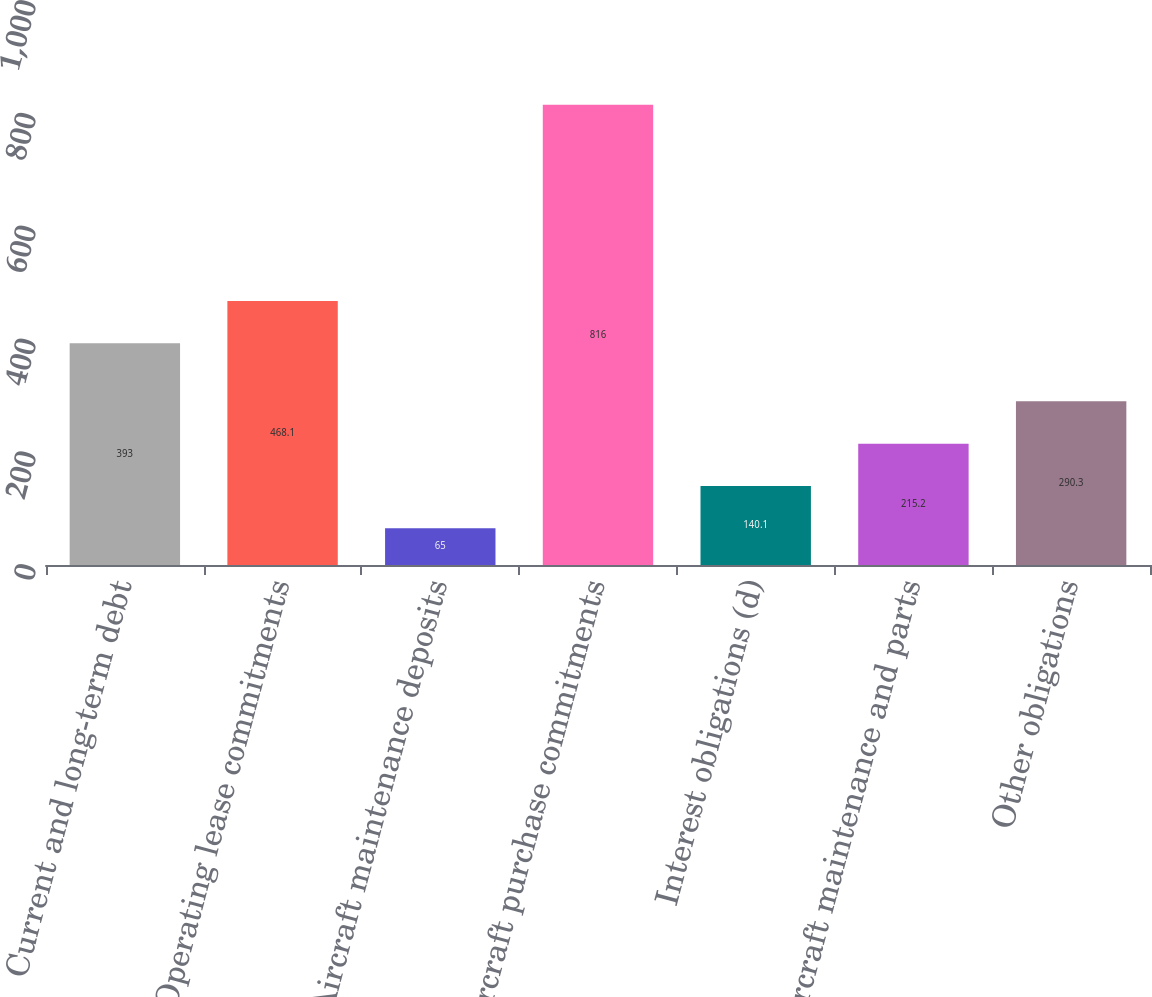Convert chart to OTSL. <chart><loc_0><loc_0><loc_500><loc_500><bar_chart><fcel>Current and long-term debt<fcel>Operating lease commitments<fcel>Aircraft maintenance deposits<fcel>Aircraft purchase commitments<fcel>Interest obligations (d)<fcel>Aircraft maintenance and parts<fcel>Other obligations<nl><fcel>393<fcel>468.1<fcel>65<fcel>816<fcel>140.1<fcel>215.2<fcel>290.3<nl></chart> 